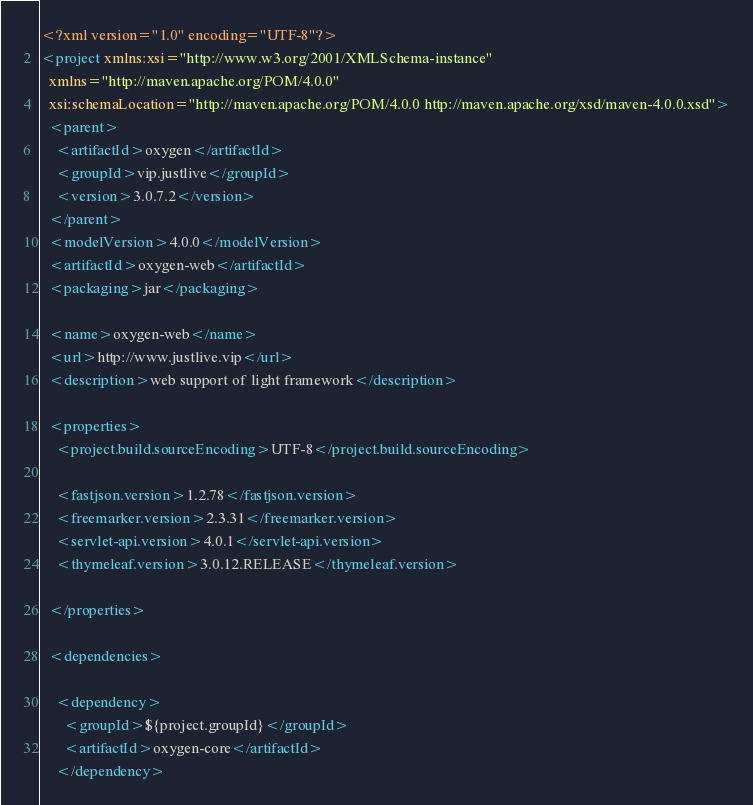Convert code to text. <code><loc_0><loc_0><loc_500><loc_500><_XML_><?xml version="1.0" encoding="UTF-8"?>
<project xmlns:xsi="http://www.w3.org/2001/XMLSchema-instance"
  xmlns="http://maven.apache.org/POM/4.0.0"
  xsi:schemaLocation="http://maven.apache.org/POM/4.0.0 http://maven.apache.org/xsd/maven-4.0.0.xsd">
  <parent>
    <artifactId>oxygen</artifactId>
    <groupId>vip.justlive</groupId>
    <version>3.0.7.2</version>
  </parent>
  <modelVersion>4.0.0</modelVersion>
  <artifactId>oxygen-web</artifactId>
  <packaging>jar</packaging>

  <name>oxygen-web</name>
  <url>http://www.justlive.vip</url>
  <description>web support of light framework</description>

  <properties>
    <project.build.sourceEncoding>UTF-8</project.build.sourceEncoding>

    <fastjson.version>1.2.78</fastjson.version>
    <freemarker.version>2.3.31</freemarker.version>
    <servlet-api.version>4.0.1</servlet-api.version>
    <thymeleaf.version>3.0.12.RELEASE</thymeleaf.version>

  </properties>

  <dependencies>

    <dependency>
      <groupId>${project.groupId}</groupId>
      <artifactId>oxygen-core</artifactId>
    </dependency>
</code> 